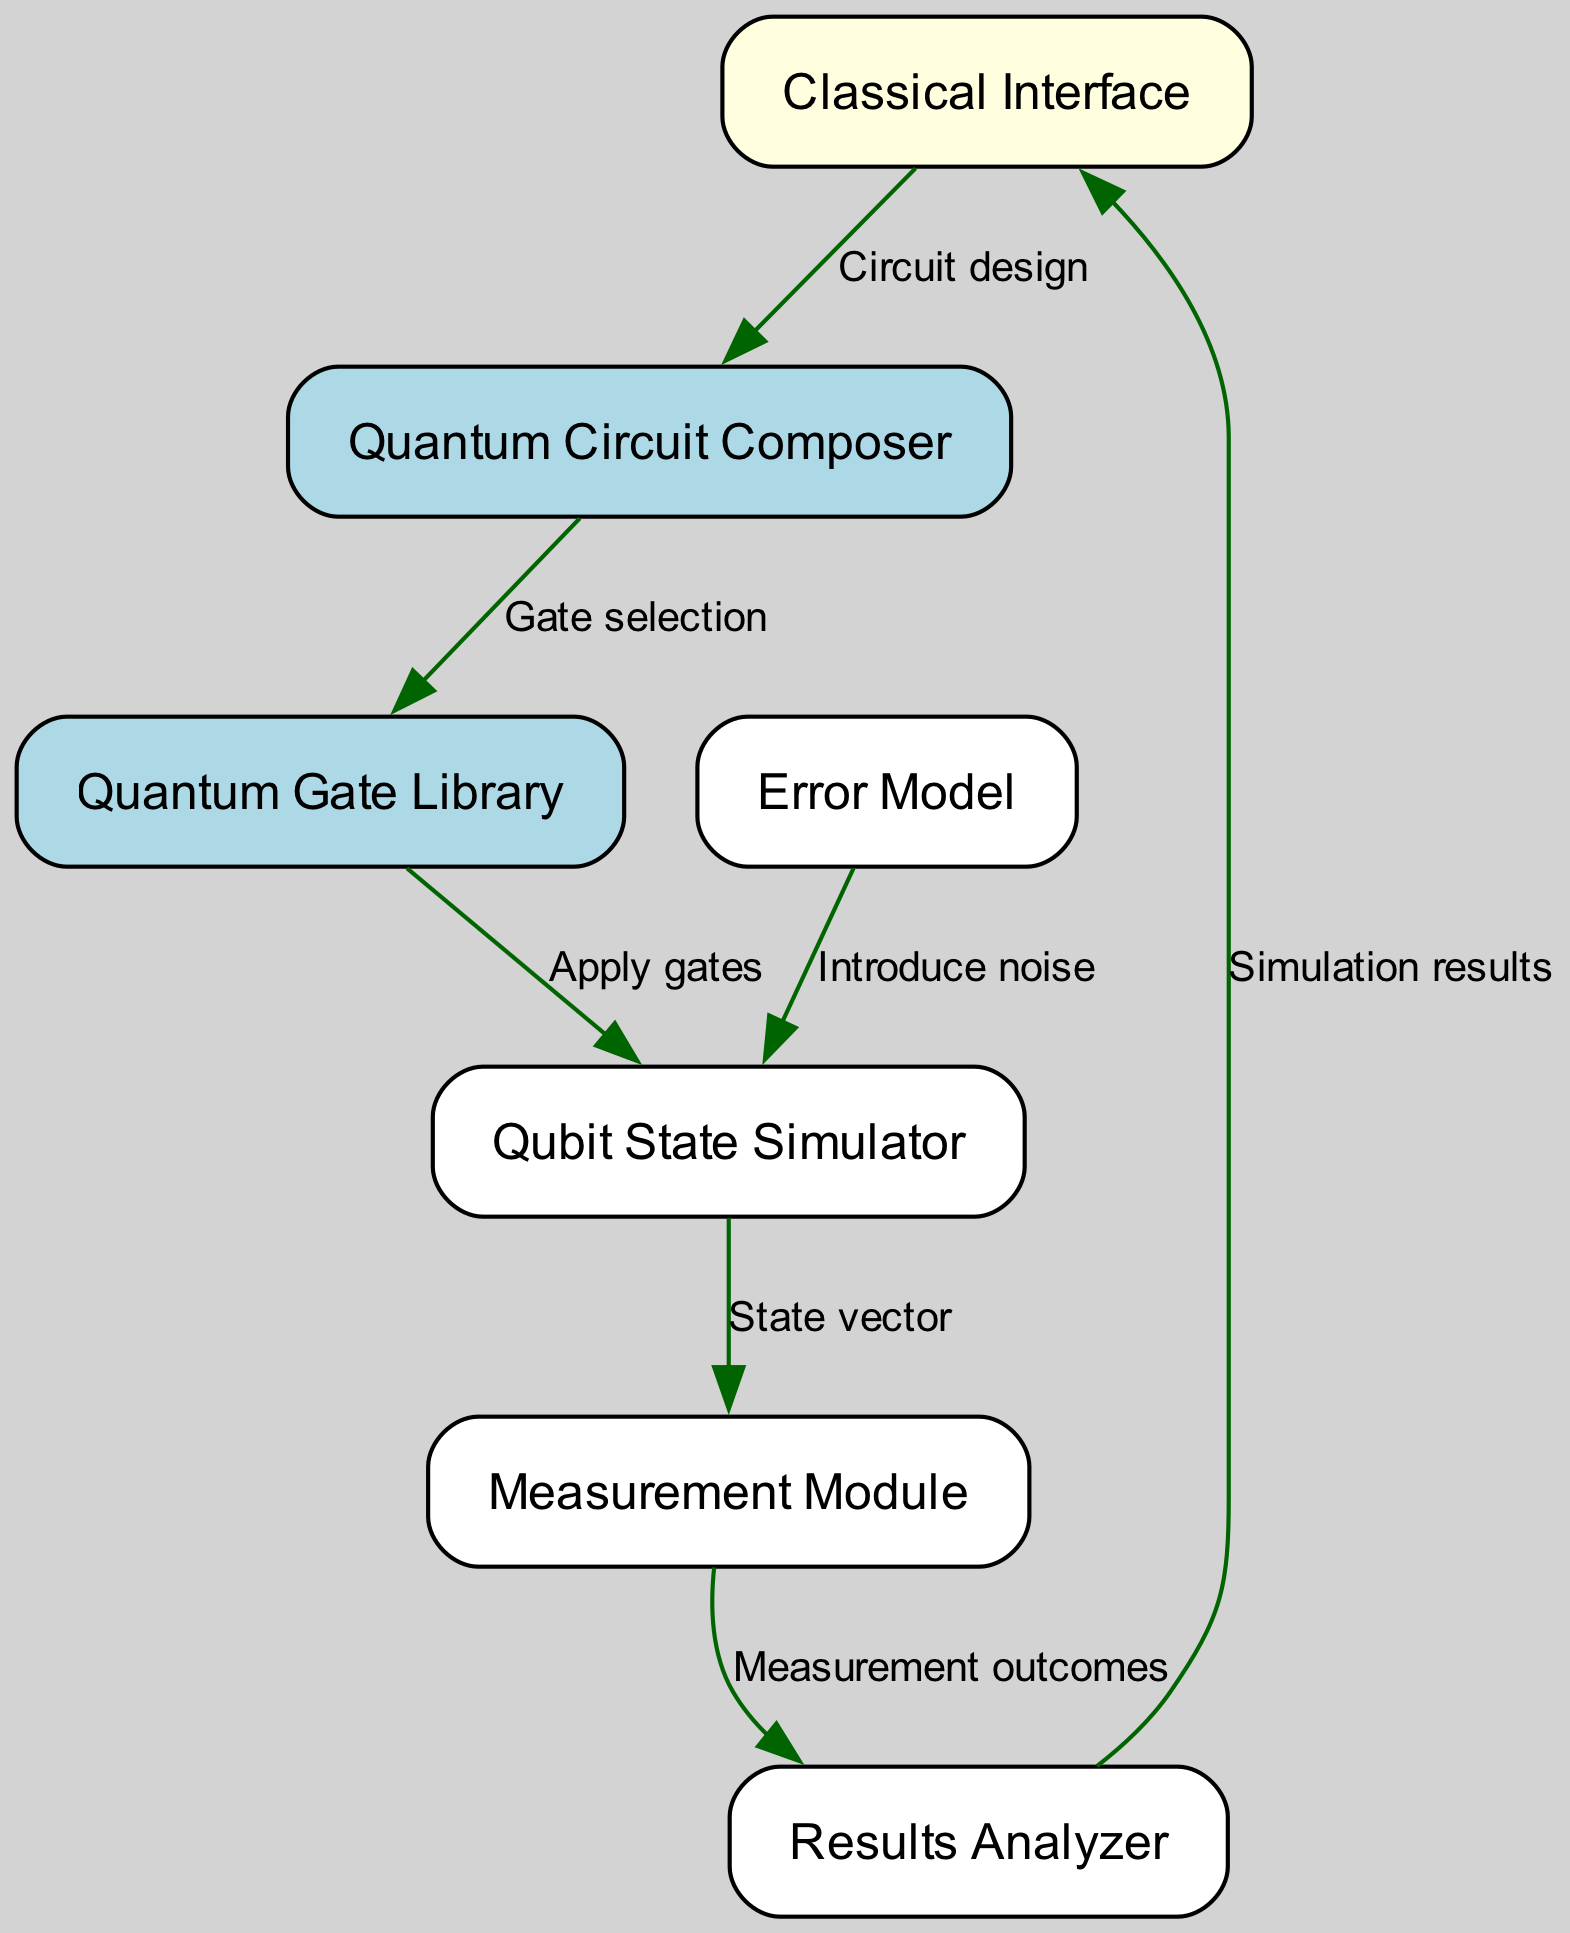What is the label of the first node? The first node in the diagram is labeled "Classical Interface". Since the nodes are displayed in a sequential order, identifying the first one gives us the answer directly.
Answer: Classical Interface How many edges are present in the diagram? To determine the number of edges, we count each connection drawn between the nodes. The data shows there are a total of 7 edges connecting various components in the quantum computing simulator.
Answer: 7 What does the 'Qubit State Simulator' receive from the 'Quantum Gate Library'? The 'Qubit State Simulator' receives the 'State vector' from the 'Quantum Gate Library'. The edge labeled "Apply gates" illustrates this flow of information as the gates are applied to the state vector.
Answer: State vector What module introduces noise to the 'Qubit State Simulator'? The 'Error Model' module introduces noise to the 'Qubit State Simulator', as indicated by the directed edge labeled "Introduce noise" that connects these two nodes.
Answer: Error Model Which component analyzes the measurement outcomes? The 'Results Analyzer' is responsible for analyzing the measurement outcomes, as shown by the edge labeled "Measurement outcomes" that connects it to the 'Measurement Module'.
Answer: Results Analyzer What is the flow of information from the 'Measurement Module' to the 'Classical Interface'? The flow of information is that the 'Measurement Module' outputs the 'Simulation results' to the 'Classical Interface'. The edge labeled "Simulation results" indicates this communication.
Answer: Simulation results What action occurs after the 'Quantum Circuit Composer'? After the 'Quantum Circuit Composer', the action of 'Gate selection' occurs, leading to the next module, which is the 'Quantum Gate Library'. This relationship is established by the directed edge representing their connection.
Answer: Gate selection What type of interface exists in the diagram? The diagram features a 'Classical Interface'. This is clearly labeled as one of the main components at the beginning of the flow, representing the classical side of the simulator.
Answer: Classical Interface What color are the quantum nodes represented in the diagram? The quantum nodes are represented in 'light blue'. The distinct color coding helps differentiate between classical and quantum components in the block diagram.
Answer: Light blue 